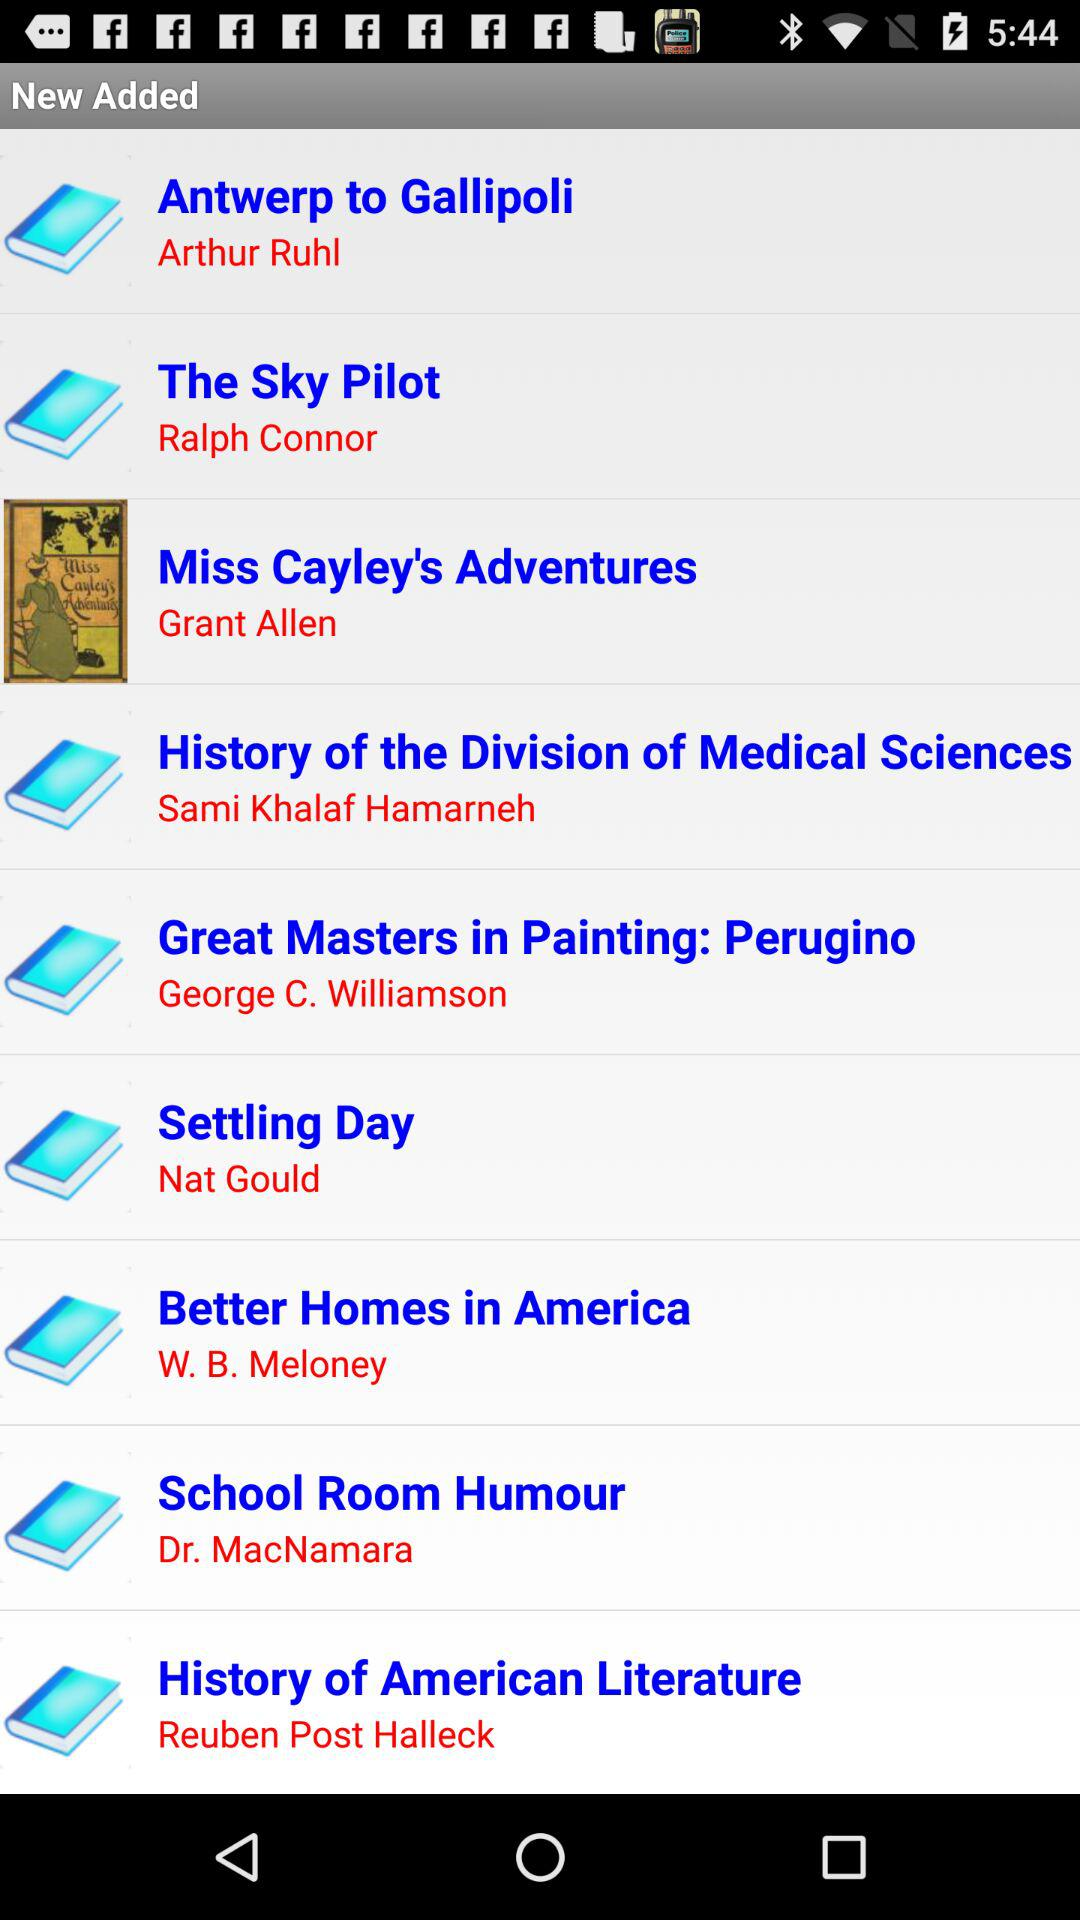Grant Allen is the author of which book? Grant Allen is the author of Miss Cayley's Adventures. 